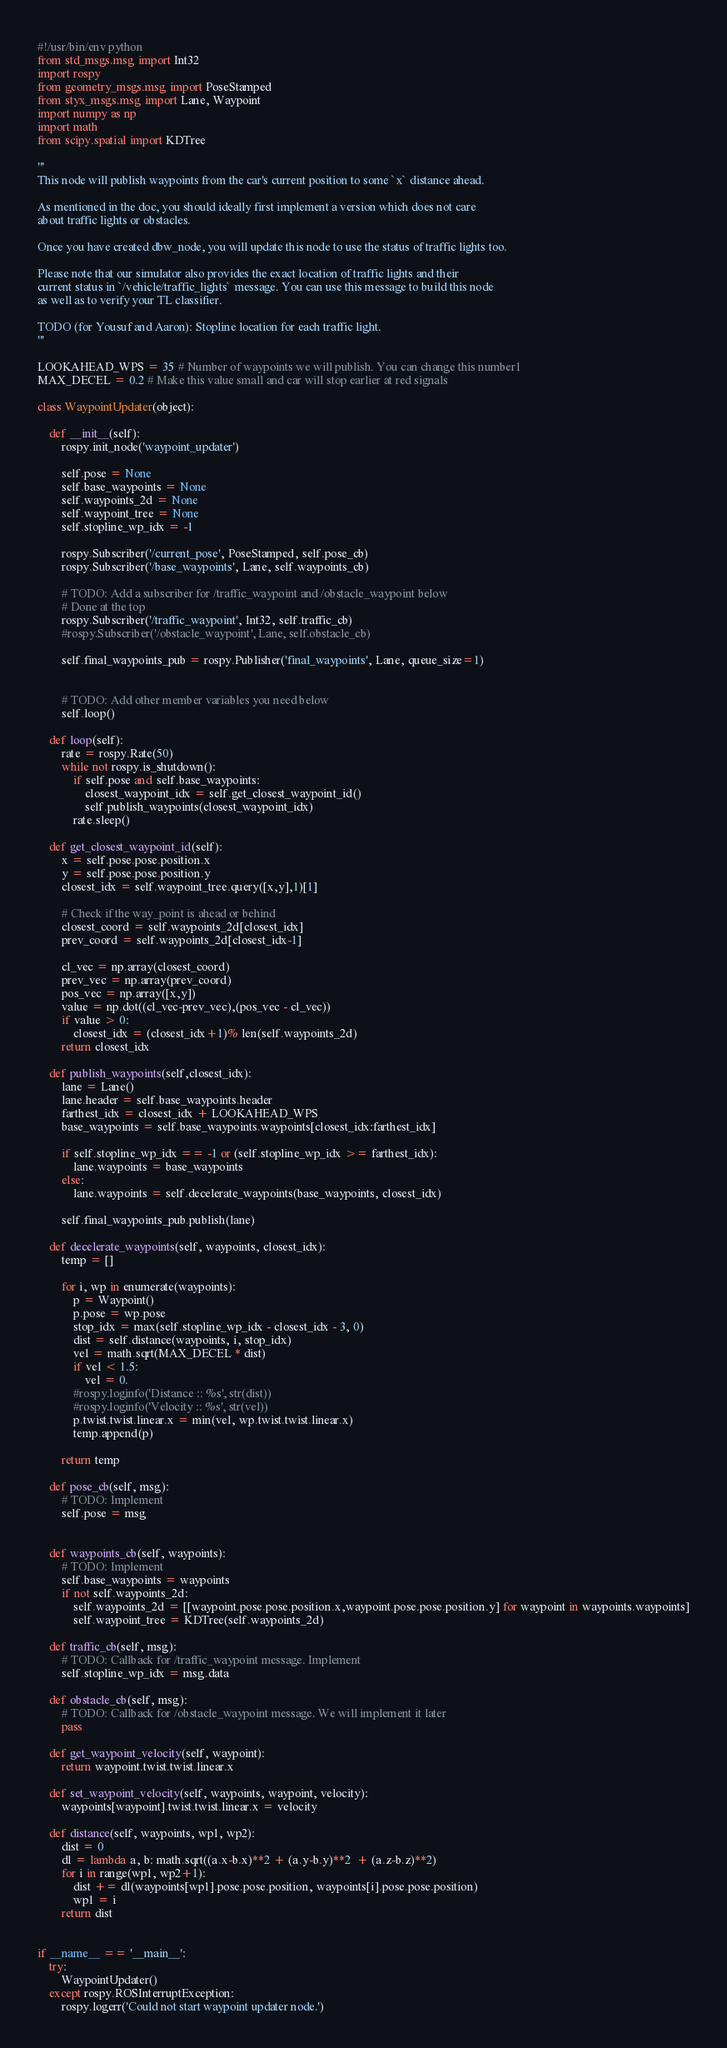Convert code to text. <code><loc_0><loc_0><loc_500><loc_500><_Python_>#!/usr/bin/env python
from std_msgs.msg import Int32
import rospy
from geometry_msgs.msg import PoseStamped
from styx_msgs.msg import Lane, Waypoint
import numpy as np
import math
from scipy.spatial import KDTree

'''
This node will publish waypoints from the car's current position to some `x` distance ahead.

As mentioned in the doc, you should ideally first implement a version which does not care
about traffic lights or obstacles.

Once you have created dbw_node, you will update this node to use the status of traffic lights too.

Please note that our simulator also provides the exact location of traffic lights and their
current status in `/vehicle/traffic_lights` message. You can use this message to build this node
as well as to verify your TL classifier.

TODO (for Yousuf and Aaron): Stopline location for each traffic light.
'''

LOOKAHEAD_WPS = 35 # Number of waypoints we will publish. You can change this number1
MAX_DECEL = 0.2 # Make this value small and car will stop earlier at red signals

class WaypointUpdater(object):
	
	def __init__(self):
		rospy.init_node('waypoint_updater')

		self.pose = None
		self.base_waypoints = None
		self.waypoints_2d = None
		self.waypoint_tree = None
		self.stopline_wp_idx = -1

		rospy.Subscriber('/current_pose', PoseStamped, self.pose_cb)
		rospy.Subscriber('/base_waypoints', Lane, self.waypoints_cb)

		# TODO: Add a subscriber for /traffic_waypoint and /obstacle_waypoint below
		# Done at the top
		rospy.Subscriber('/traffic_waypoint', Int32, self.traffic_cb)
		#rospy.Subscriber('/obstacle_waypoint', Lane, self.obstacle_cb)

		self.final_waypoints_pub = rospy.Publisher('final_waypoints', Lane, queue_size=1)
	

		# TODO: Add other member variables you need below
		self.loop()
	
	def loop(self):
		rate = rospy.Rate(50)
		while not rospy.is_shutdown():
			if self.pose and self.base_waypoints:
				closest_waypoint_idx = self.get_closest_waypoint_id()
				self.publish_waypoints(closest_waypoint_idx)
			rate.sleep()

	def get_closest_waypoint_id(self):
		x = self.pose.pose.position.x
		y = self.pose.pose.position.y
		closest_idx = self.waypoint_tree.query([x,y],1)[1]

		# Check if the way_point is ahead or behind
		closest_coord = self.waypoints_2d[closest_idx]
		prev_coord = self.waypoints_2d[closest_idx-1]

		cl_vec = np.array(closest_coord)
		prev_vec = np.array(prev_coord)
		pos_vec = np.array([x,y])
		value = np.dot((cl_vec-prev_vec),(pos_vec - cl_vec))
		if value > 0:
			closest_idx = (closest_idx+1)% len(self.waypoints_2d)
		return closest_idx

	def publish_waypoints(self,closest_idx):
		lane = Lane()
		lane.header = self.base_waypoints.header
		farthest_idx = closest_idx + LOOKAHEAD_WPS
		base_waypoints = self.base_waypoints.waypoints[closest_idx:farthest_idx]

		if self.stopline_wp_idx == -1 or (self.stopline_wp_idx >= farthest_idx):
			lane.waypoints = base_waypoints
		else:
			lane.waypoints = self.decelerate_waypoints(base_waypoints, closest_idx)

		self.final_waypoints_pub.publish(lane)

	def decelerate_waypoints(self, waypoints, closest_idx):
		temp = []

		for i, wp in enumerate(waypoints):
			p = Waypoint()
			p.pose = wp.pose
			stop_idx = max(self.stopline_wp_idx - closest_idx - 3, 0)
			dist = self.distance(waypoints, i, stop_idx)
			vel = math.sqrt(MAX_DECEL * dist)
			if vel < 1.5:
				vel = 0.
			#rospy.loginfo('Distance :: %s', str(dist))
			#rospy.loginfo('Velocity :: %s', str(vel))
			p.twist.twist.linear.x = min(vel, wp.twist.twist.linear.x)
			temp.append(p)

		return temp

	def pose_cb(self, msg):
		# TODO: Implement
		self.pose = msg


	def waypoints_cb(self, waypoints):
		# TODO: Implement
		self.base_waypoints = waypoints
		if not self.waypoints_2d:
			self.waypoints_2d = [[waypoint.pose.pose.position.x,waypoint.pose.pose.position.y] for waypoint in waypoints.waypoints]
			self.waypoint_tree = KDTree(self.waypoints_2d)

	def traffic_cb(self, msg):
		# TODO: Callback for /traffic_waypoint message. Implement
		self.stopline_wp_idx = msg.data

	def obstacle_cb(self, msg):
		# TODO: Callback for /obstacle_waypoint message. We will implement it later
		pass

	def get_waypoint_velocity(self, waypoint):
		return waypoint.twist.twist.linear.x

	def set_waypoint_velocity(self, waypoints, waypoint, velocity):
		waypoints[waypoint].twist.twist.linear.x = velocity

	def distance(self, waypoints, wp1, wp2):
		dist = 0
		dl = lambda a, b: math.sqrt((a.x-b.x)**2 + (a.y-b.y)**2  + (a.z-b.z)**2)
		for i in range(wp1, wp2+1):
			dist += dl(waypoints[wp1].pose.pose.position, waypoints[i].pose.pose.position)
			wp1 = i
		return dist


if __name__ == '__main__':
	try:
		WaypointUpdater()
	except rospy.ROSInterruptException:
		rospy.logerr('Could not start waypoint updater node.')
</code> 